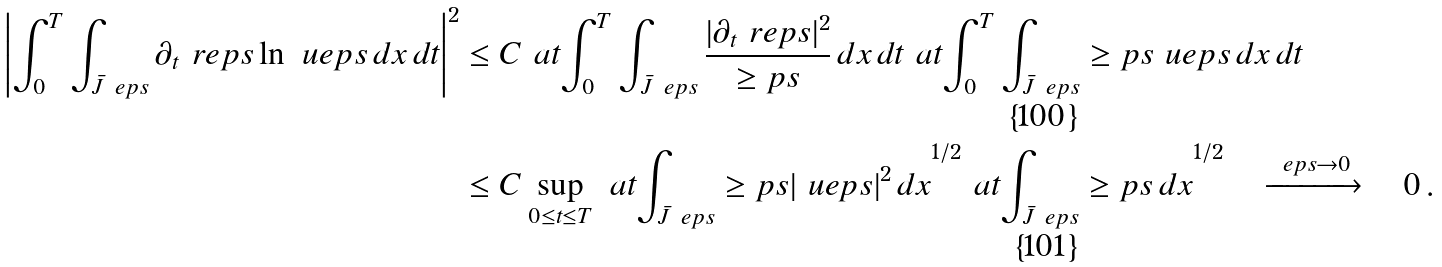Convert formula to latex. <formula><loc_0><loc_0><loc_500><loc_500>\left | \int _ { 0 } ^ { T } \int _ { \bar { J } _ { \ } e p s } \partial _ { t } \ r e p s \ln \ u e p s \, d x \, d t \right | ^ { 2 } & \leq C \ a t { \int _ { 0 } ^ { T } \int _ { \bar { J } _ { \ } e p s } \frac { | \partial _ { t } \ r e p s | ^ { 2 } } { \geq p s } \, d x \, d t } \ a t { \int _ { 0 } ^ { T } \int _ { \bar { J } _ { \ } e p s } \geq p s { \ u e p s } \, d x \, d t } \\ & \leq C \sup _ { 0 \leq { t } \leq { T } } \ a t { \int _ { \bar { J } _ { \ } e p s } \geq p s | \ u e p s | ^ { 2 } \, d x } ^ { 1 / 2 } \ a t { \int _ { \bar { J } _ { \ } e p s } \geq p s \, d x } ^ { 1 / 2 } \quad \xrightarrow { \ e p s \to 0 } \quad 0 \, .</formula> 